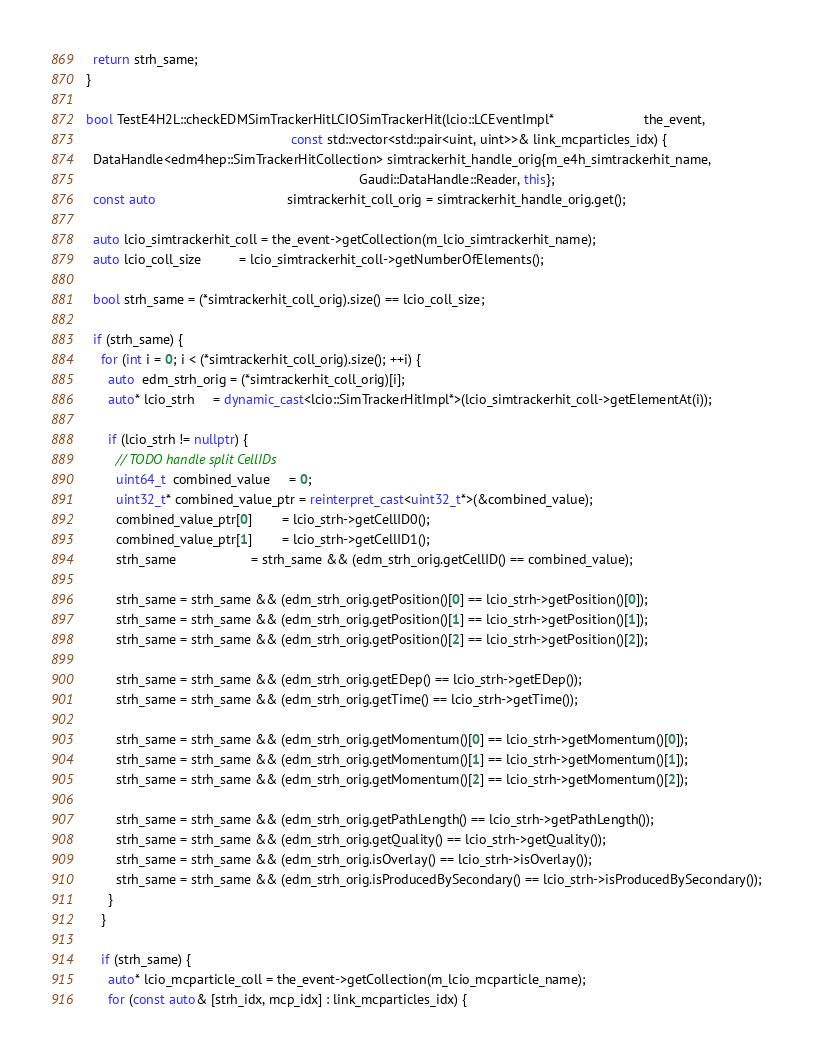Convert code to text. <code><loc_0><loc_0><loc_500><loc_500><_C++_>  return strh_same;
}

bool TestE4H2L::checkEDMSimTrackerHitLCIOSimTrackerHit(lcio::LCEventImpl*                        the_event,
                                                       const std::vector<std::pair<uint, uint>>& link_mcparticles_idx) {
  DataHandle<edm4hep::SimTrackerHitCollection> simtrackerhit_handle_orig{m_e4h_simtrackerhit_name,
                                                                         Gaudi::DataHandle::Reader, this};
  const auto                                   simtrackerhit_coll_orig = simtrackerhit_handle_orig.get();

  auto lcio_simtrackerhit_coll = the_event->getCollection(m_lcio_simtrackerhit_name);
  auto lcio_coll_size          = lcio_simtrackerhit_coll->getNumberOfElements();

  bool strh_same = (*simtrackerhit_coll_orig).size() == lcio_coll_size;

  if (strh_same) {
    for (int i = 0; i < (*simtrackerhit_coll_orig).size(); ++i) {
      auto  edm_strh_orig = (*simtrackerhit_coll_orig)[i];
      auto* lcio_strh     = dynamic_cast<lcio::SimTrackerHitImpl*>(lcio_simtrackerhit_coll->getElementAt(i));

      if (lcio_strh != nullptr) {
        // TODO handle split CellIDs
        uint64_t  combined_value     = 0;
        uint32_t* combined_value_ptr = reinterpret_cast<uint32_t*>(&combined_value);
        combined_value_ptr[0]        = lcio_strh->getCellID0();
        combined_value_ptr[1]        = lcio_strh->getCellID1();
        strh_same                    = strh_same && (edm_strh_orig.getCellID() == combined_value);

        strh_same = strh_same && (edm_strh_orig.getPosition()[0] == lcio_strh->getPosition()[0]);
        strh_same = strh_same && (edm_strh_orig.getPosition()[1] == lcio_strh->getPosition()[1]);
        strh_same = strh_same && (edm_strh_orig.getPosition()[2] == lcio_strh->getPosition()[2]);

        strh_same = strh_same && (edm_strh_orig.getEDep() == lcio_strh->getEDep());
        strh_same = strh_same && (edm_strh_orig.getTime() == lcio_strh->getTime());

        strh_same = strh_same && (edm_strh_orig.getMomentum()[0] == lcio_strh->getMomentum()[0]);
        strh_same = strh_same && (edm_strh_orig.getMomentum()[1] == lcio_strh->getMomentum()[1]);
        strh_same = strh_same && (edm_strh_orig.getMomentum()[2] == lcio_strh->getMomentum()[2]);

        strh_same = strh_same && (edm_strh_orig.getPathLength() == lcio_strh->getPathLength());
        strh_same = strh_same && (edm_strh_orig.getQuality() == lcio_strh->getQuality());
        strh_same = strh_same && (edm_strh_orig.isOverlay() == lcio_strh->isOverlay());
        strh_same = strh_same && (edm_strh_orig.isProducedBySecondary() == lcio_strh->isProducedBySecondary());
      }
    }

    if (strh_same) {
      auto* lcio_mcparticle_coll = the_event->getCollection(m_lcio_mcparticle_name);
      for (const auto& [strh_idx, mcp_idx] : link_mcparticles_idx) {</code> 